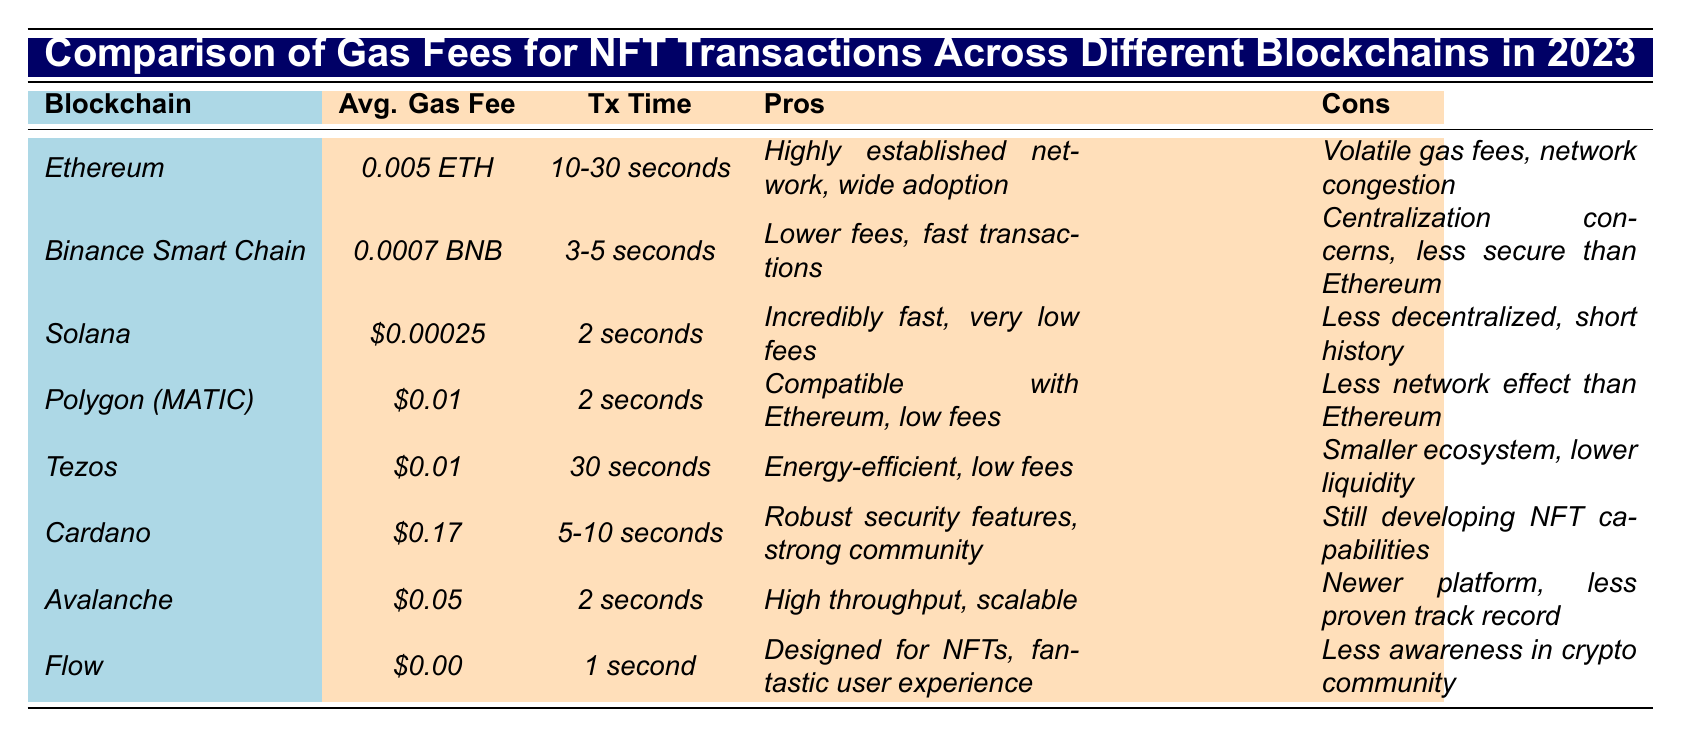What is the average gas fee for Ethereum? Referring to the table, the average gas fee for Ethereum is stated as *0.005 ETH*.
Answer: 0.005 ETH Which blockchain has the lowest average gas fee? By comparing the average gas fees listed, Solana has the lowest average gas fee at *$0.00025*.
Answer: Solana How long does it take for a transaction on Flow? According to the table, the transaction time for Flow is noted as *1 second*.
Answer: 1 second What are the pros of using Polygon (MATIC)? The pros listed for Polygon (MATIC) in the table are *compatible with Ethereum, low fees*.
Answer: Compatible with Ethereum, low fees Is the average gas fee on Tezos higher than on Avalanche? The average gas fee for Tezos is *$0.01* and for Avalanche, it is *$0.05*. Since $0.01 < $0.05, the average fee on Tezos is actually lower than Avalanche.
Answer: No How do the average gas fees of Ethereum and Binance Smart Chain compare? Ethereum has an average gas fee of *0.005 ETH* and Binance Smart Chain has an average gas fee of *0.0007 BNB*, which is significantly lower when converted. Thus, Binance Smart Chain has lower fees.
Answer: Binance Smart Chain has lower fees Which blockchain has the fastest transaction time? Solana has the fastest transaction time listed as *2 seconds*, which is confirmed by the other entries.
Answer: Solana Are the gas fees on Tezos and Polygon the same? Both Tezos and Polygon have an average gas fee of *$0.01*, thus confirming they are equal.
Answer: Yes What advantages does Solana offer according to the table? The advantages of Solana, as mentioned in the table, are *incredibly fast, very low fees*.
Answer: Incredibly fast, very low fees If someone values low transaction times, which blockchain should they choose? Solana boasts the lowest transaction time of *2 seconds* alongside Avalanche also at *2 seconds*. Therefore, both would be optimal choices.
Answer: Solana or Avalanche How does the transaction time of Cardano compare to that of Ethereum? Cardano’s transaction time is listed as *5-10 seconds*, which is longer than Ethereum's *10-30 seconds* but could be shorter depending on the specific transaction.
Answer: Cardano's time can be shorter or longer than Ethereum's depending on the transaction case 